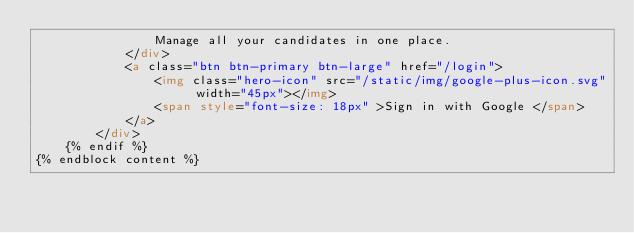Convert code to text. <code><loc_0><loc_0><loc_500><loc_500><_HTML_>                Manage all your candidates in one place. 
            </div>
            <a class="btn btn-primary btn-large" href="/login">
                <img class="hero-icon" src="/static/img/google-plus-icon.svg" width="45px"></img>
                <span style="font-size: 18px" >Sign in with Google </span>
            </a>
        </div>
    {% endif %}
{% endblock content %}
</code> 